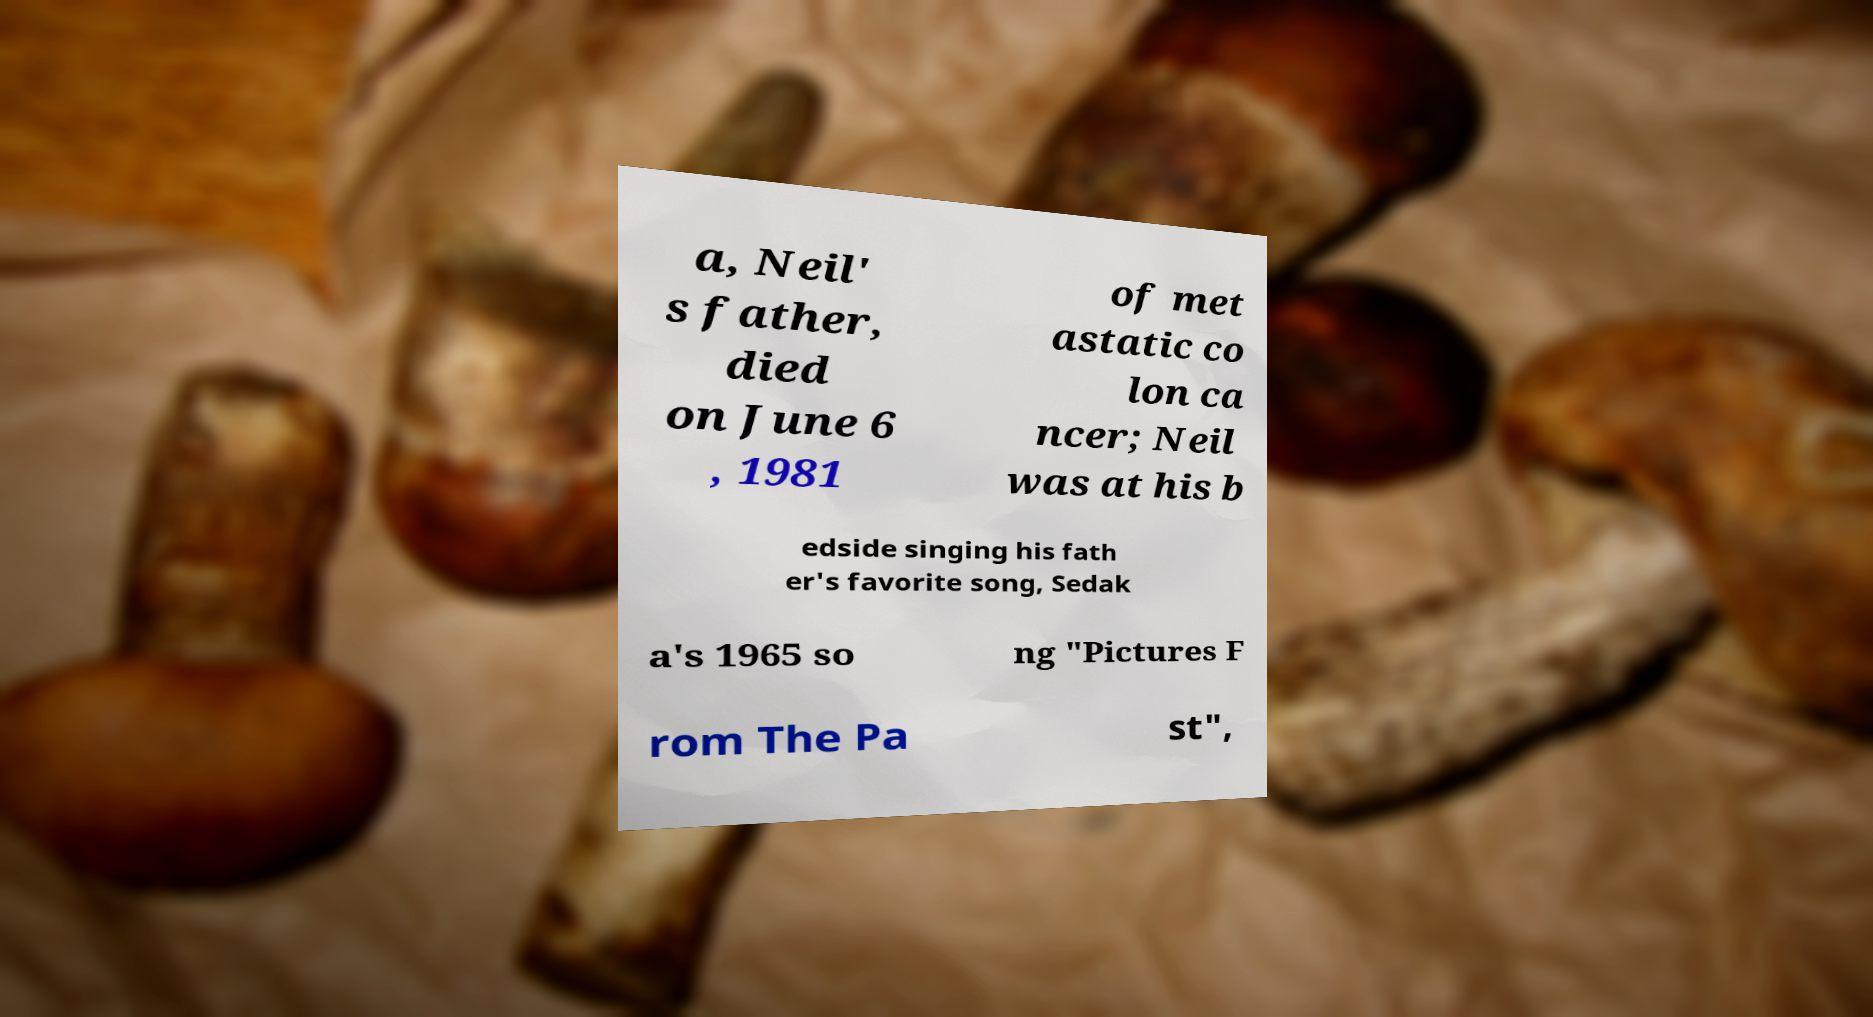Please read and relay the text visible in this image. What does it say? a, Neil' s father, died on June 6 , 1981 of met astatic co lon ca ncer; Neil was at his b edside singing his fath er's favorite song, Sedak a's 1965 so ng "Pictures F rom The Pa st", 